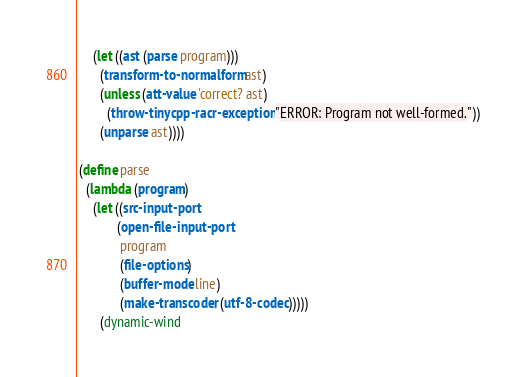Convert code to text. <code><loc_0><loc_0><loc_500><loc_500><_Scheme_>     (let ((ast (parse program)))
       (transform-to-normalform ast)
       (unless (att-value 'correct? ast)
         (throw-tinycpp-racr-exception "ERROR: Program not well-formed."))
       (unparse ast))))
 
 (define parse
   (lambda (program)
     (let ((src-input-port
            (open-file-input-port
             program
             (file-options)
             (buffer-mode line)
             (make-transcoder (utf-8-codec)))))
       (dynamic-wind</code> 